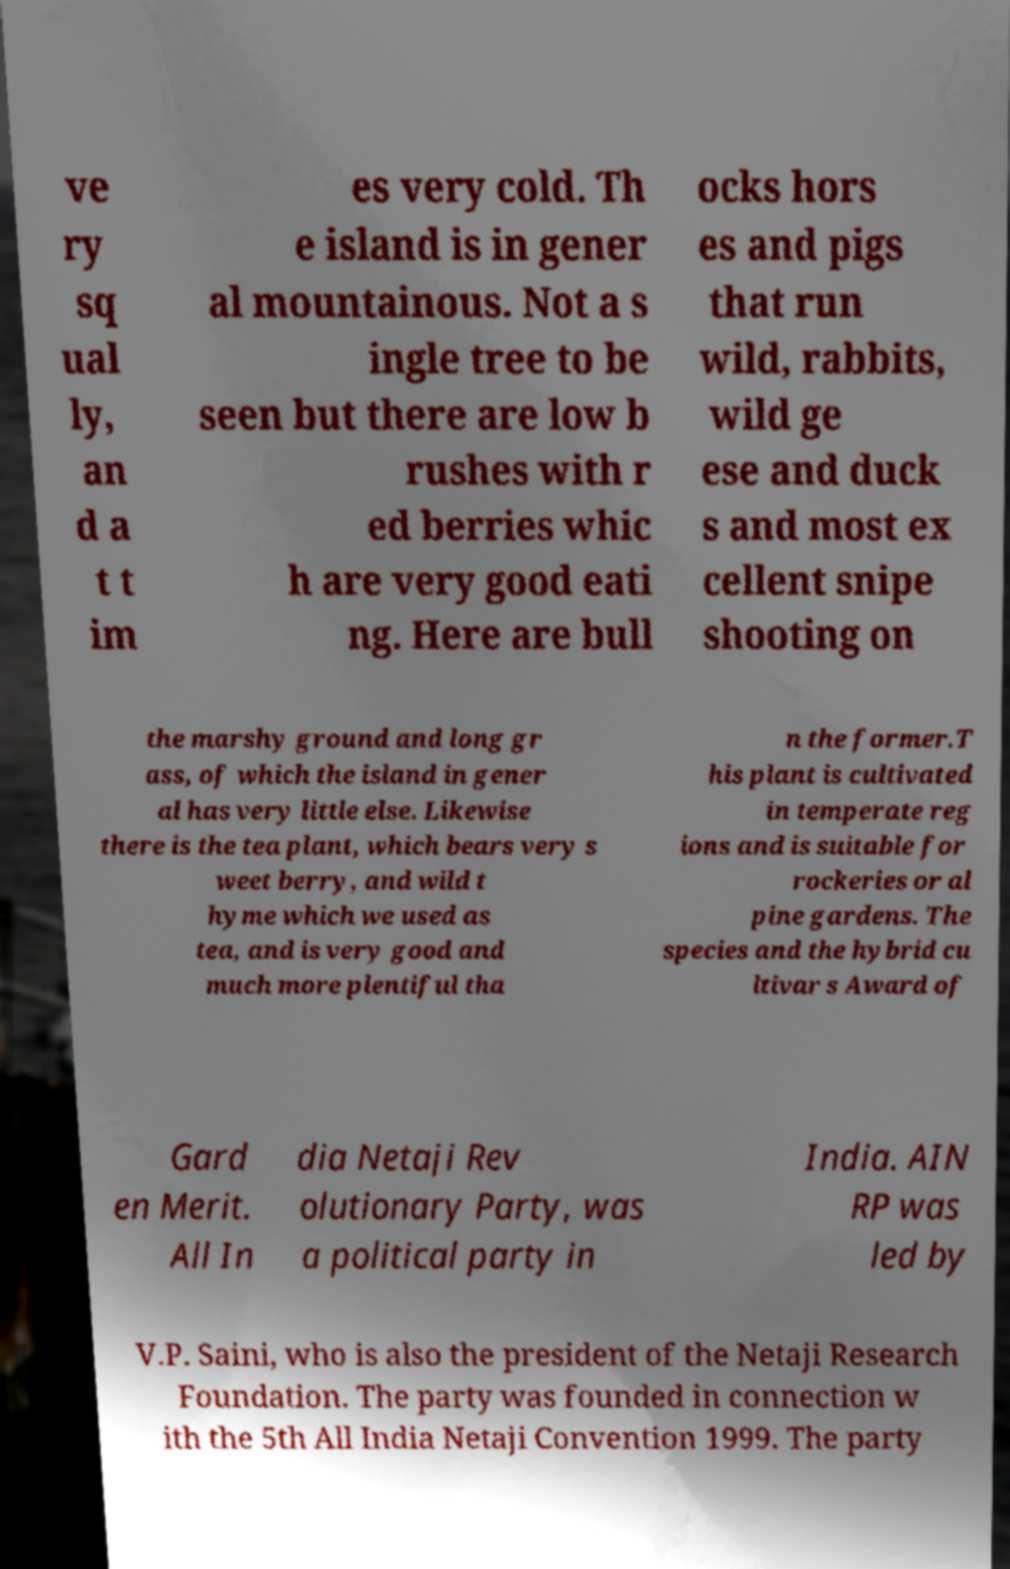What messages or text are displayed in this image? I need them in a readable, typed format. ve ry sq ual ly, an d a t t im es very cold. Th e island is in gener al mountainous. Not a s ingle tree to be seen but there are low b rushes with r ed berries whic h are very good eati ng. Here are bull ocks hors es and pigs that run wild, rabbits, wild ge ese and duck s and most ex cellent snipe shooting on the marshy ground and long gr ass, of which the island in gener al has very little else. Likewise there is the tea plant, which bears very s weet berry, and wild t hyme which we used as tea, and is very good and much more plentiful tha n the former.T his plant is cultivated in temperate reg ions and is suitable for rockeries or al pine gardens. The species and the hybrid cu ltivar s Award of Gard en Merit. All In dia Netaji Rev olutionary Party, was a political party in India. AIN RP was led by V.P. Saini, who is also the president of the Netaji Research Foundation. The party was founded in connection w ith the 5th All India Netaji Convention 1999. The party 